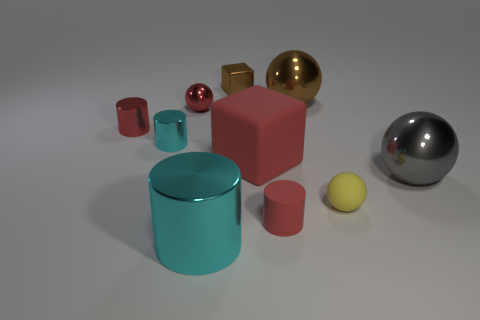Subtract all purple spheres. How many cyan cylinders are left? 2 Subtract all matte balls. How many balls are left? 3 Subtract 1 spheres. How many spheres are left? 3 Subtract all gray balls. How many balls are left? 3 Subtract all green spheres. Subtract all gray cubes. How many spheres are left? 4 Subtract all spheres. How many objects are left? 6 Add 6 large cyan metallic blocks. How many large cyan metallic blocks exist? 6 Subtract 0 green blocks. How many objects are left? 10 Subtract all tiny brown blocks. Subtract all tiny cylinders. How many objects are left? 6 Add 2 brown shiny cubes. How many brown shiny cubes are left? 3 